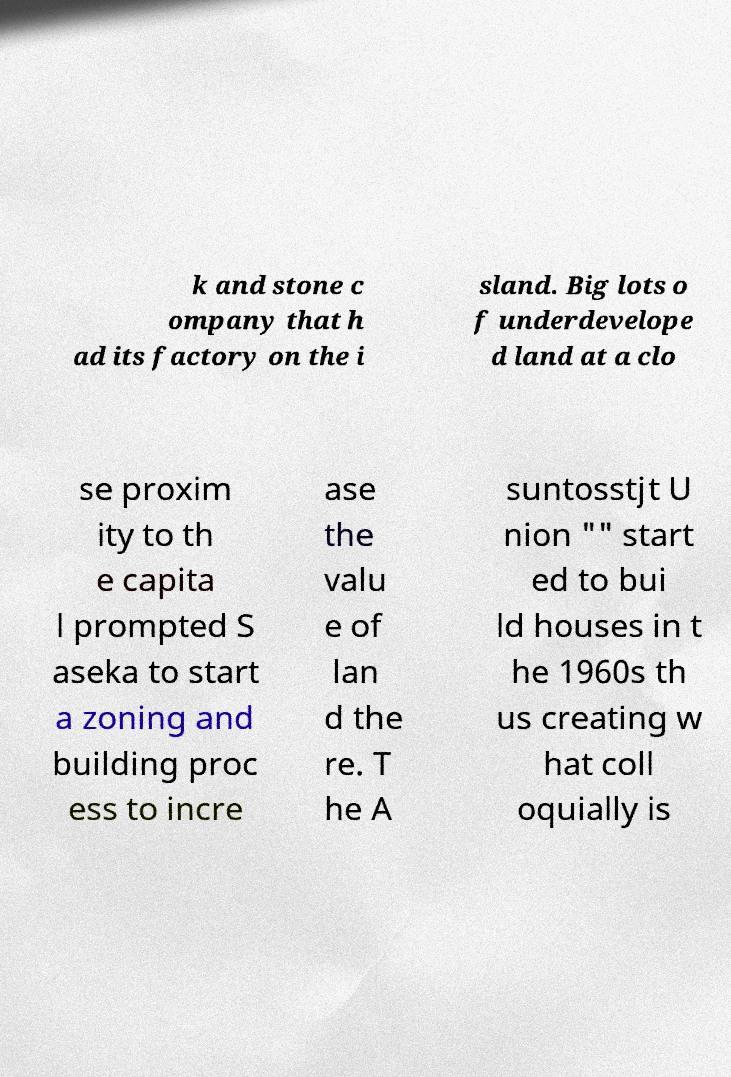Could you assist in decoding the text presented in this image and type it out clearly? k and stone c ompany that h ad its factory on the i sland. Big lots o f underdevelope d land at a clo se proxim ity to th e capita l prompted S aseka to start a zoning and building proc ess to incre ase the valu e of lan d the re. T he A suntosstjt U nion "" start ed to bui ld houses in t he 1960s th us creating w hat coll oquially is 